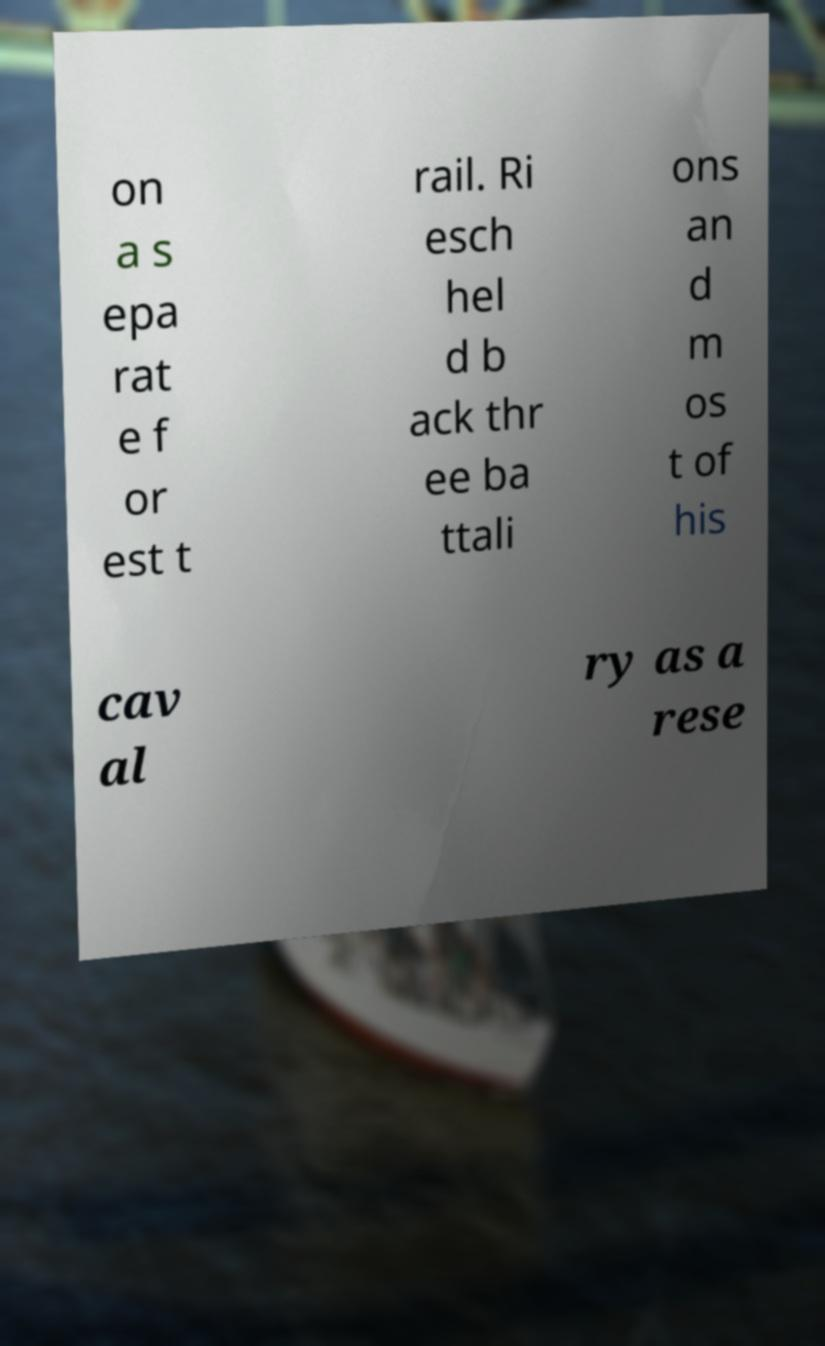I need the written content from this picture converted into text. Can you do that? on a s epa rat e f or est t rail. Ri esch hel d b ack thr ee ba ttali ons an d m os t of his cav al ry as a rese 